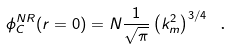<formula> <loc_0><loc_0><loc_500><loc_500>\phi _ { C } ^ { N R } ( r = 0 ) = N \frac { 1 } { \sqrt { \pi } } \left ( k ^ { 2 } _ { m } \right ) ^ { 3 / 4 } \text { .}</formula> 